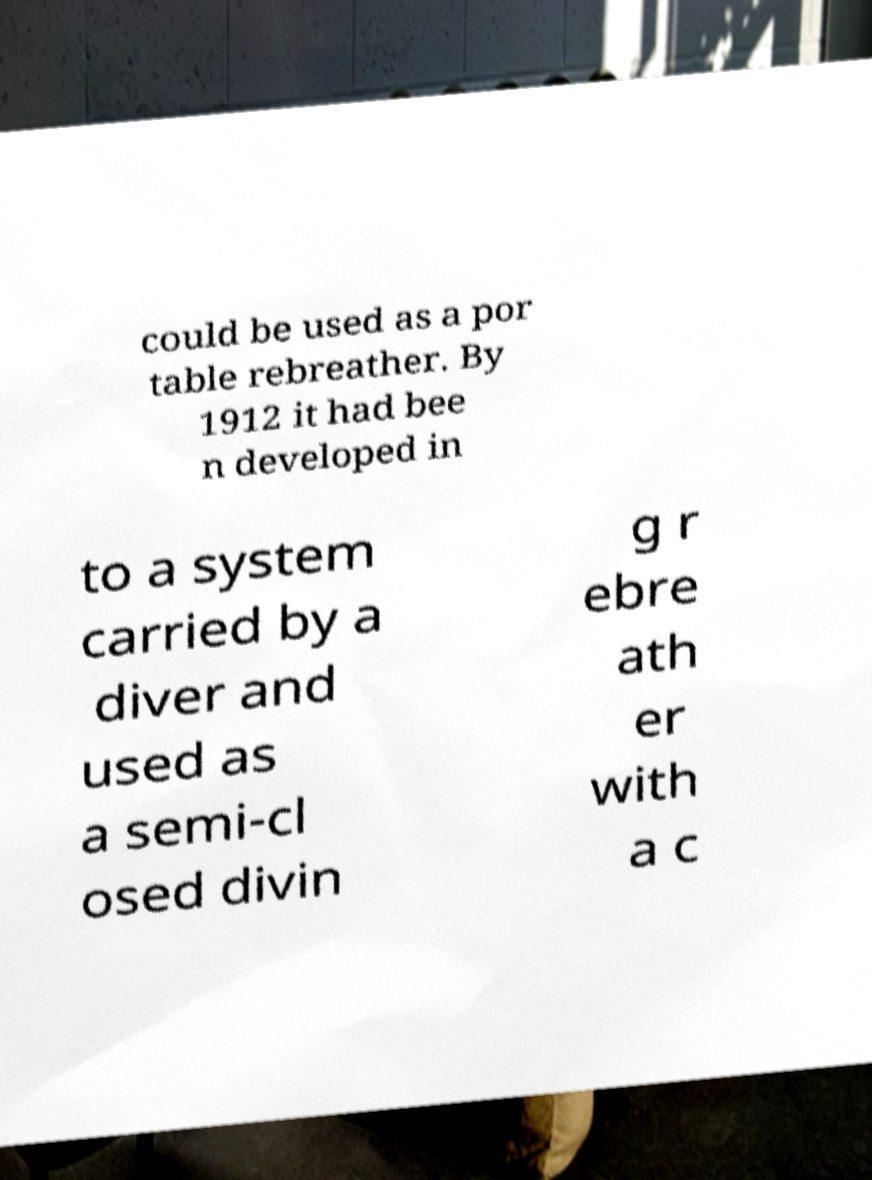What messages or text are displayed in this image? I need them in a readable, typed format. could be used as a por table rebreather. By 1912 it had bee n developed in to a system carried by a diver and used as a semi-cl osed divin g r ebre ath er with a c 